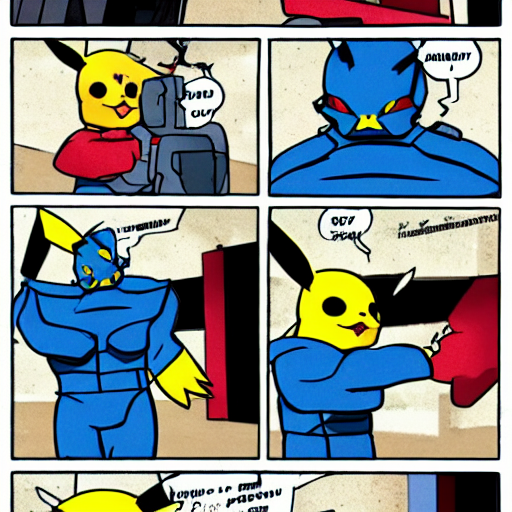What is lost in the photograph?
A. Texture details
B. Contrast levels
C. Sharpness
D. Color accuracy Upon examining the image, it appears that the perceived loss of sharpness is most significant. The outlines and details within the image exhibit a certain softness which reduces the visual clarity. As such, option C, Sharpness, is the aspect that is most noticeably lacking in this image. 